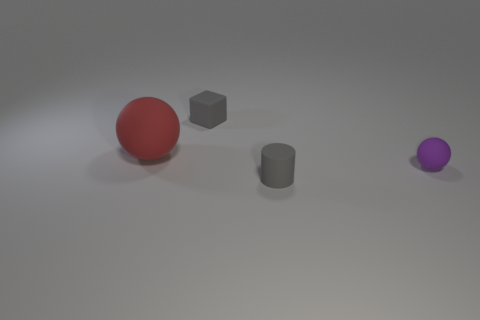There is a purple matte sphere that is right of the gray cylinder; is it the same size as the matte sphere on the left side of the block?
Give a very brief answer. No. There is a small gray cylinder that is in front of the small rubber block; what number of purple objects are left of it?
Provide a short and direct response. 0. Does the small gray thing that is in front of the tiny ball have the same material as the large red thing?
Provide a short and direct response. Yes. How big is the matte ball that is right of the tiny gray matte object in front of the red matte ball?
Provide a short and direct response. Small. What is the size of the rubber thing on the right side of the tiny gray matte object in front of the small object that is behind the red object?
Offer a very short reply. Small. Does the tiny matte thing on the right side of the small cylinder have the same shape as the large red object that is behind the tiny purple matte ball?
Keep it short and to the point. Yes. What number of other objects are the same color as the small sphere?
Ensure brevity in your answer.  0. Is the size of the matte thing that is behind the red matte sphere the same as the red object?
Offer a very short reply. No. Are the small gray thing behind the tiny rubber cylinder and the tiny object on the right side of the gray rubber cylinder made of the same material?
Your response must be concise. Yes. Are there any cubes that have the same size as the red matte object?
Your answer should be very brief. No. 